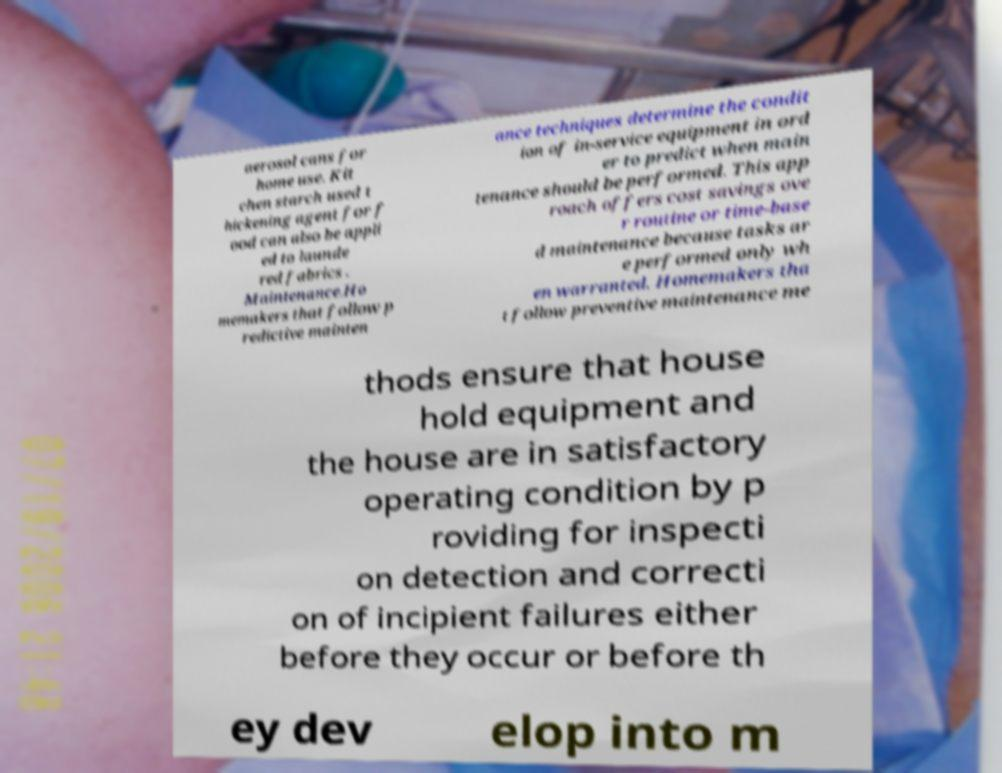There's text embedded in this image that I need extracted. Can you transcribe it verbatim? aerosol cans for home use. Kit chen starch used t hickening agent for f ood can also be appli ed to launde red fabrics . Maintenance.Ho memakers that follow p redictive mainten ance techniques determine the condit ion of in-service equipment in ord er to predict when main tenance should be performed. This app roach offers cost savings ove r routine or time-base d maintenance because tasks ar e performed only wh en warranted. Homemakers tha t follow preventive maintenance me thods ensure that house hold equipment and the house are in satisfactory operating condition by p roviding for inspecti on detection and correcti on of incipient failures either before they occur or before th ey dev elop into m 